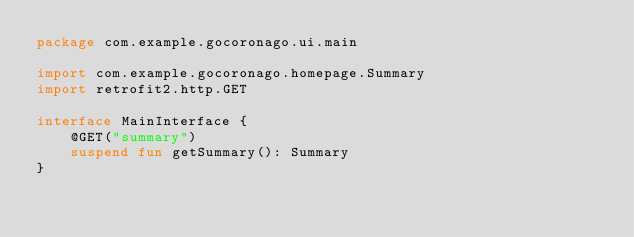<code> <loc_0><loc_0><loc_500><loc_500><_Kotlin_>package com.example.gocoronago.ui.main

import com.example.gocoronago.homepage.Summary
import retrofit2.http.GET

interface MainInterface {
    @GET("summary")
    suspend fun getSummary(): Summary
}</code> 